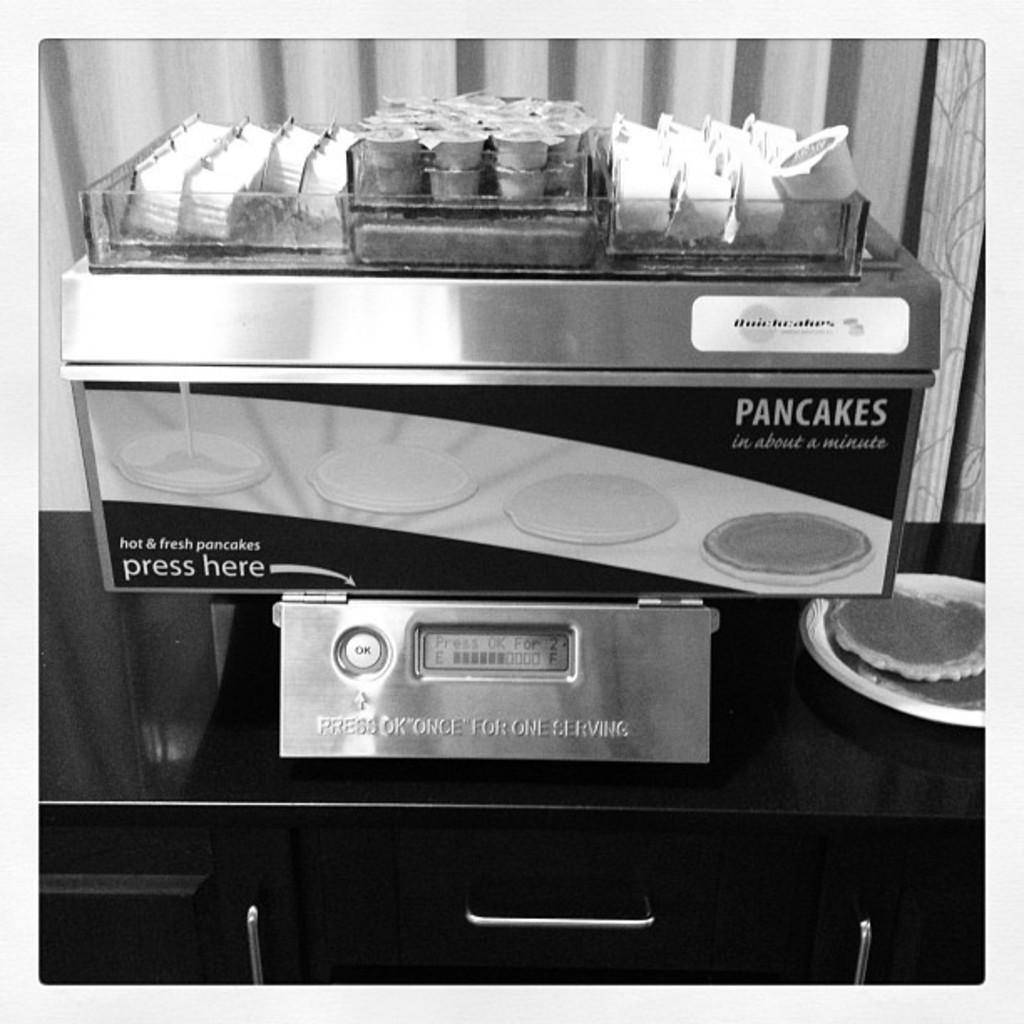Provide a one-sentence caption for the provided image. A person should press the "ok" button one time for a single serving of pancakes. 